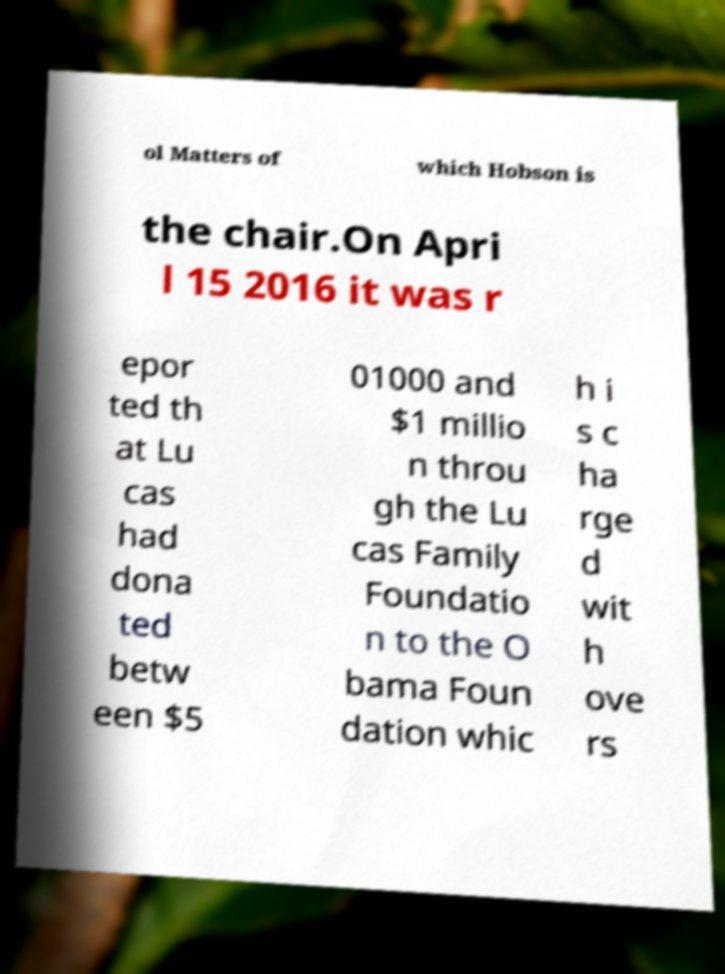Could you extract and type out the text from this image? ol Matters of which Hobson is the chair.On Apri l 15 2016 it was r epor ted th at Lu cas had dona ted betw een $5 01000 and $1 millio n throu gh the Lu cas Family Foundatio n to the O bama Foun dation whic h i s c ha rge d wit h ove rs 